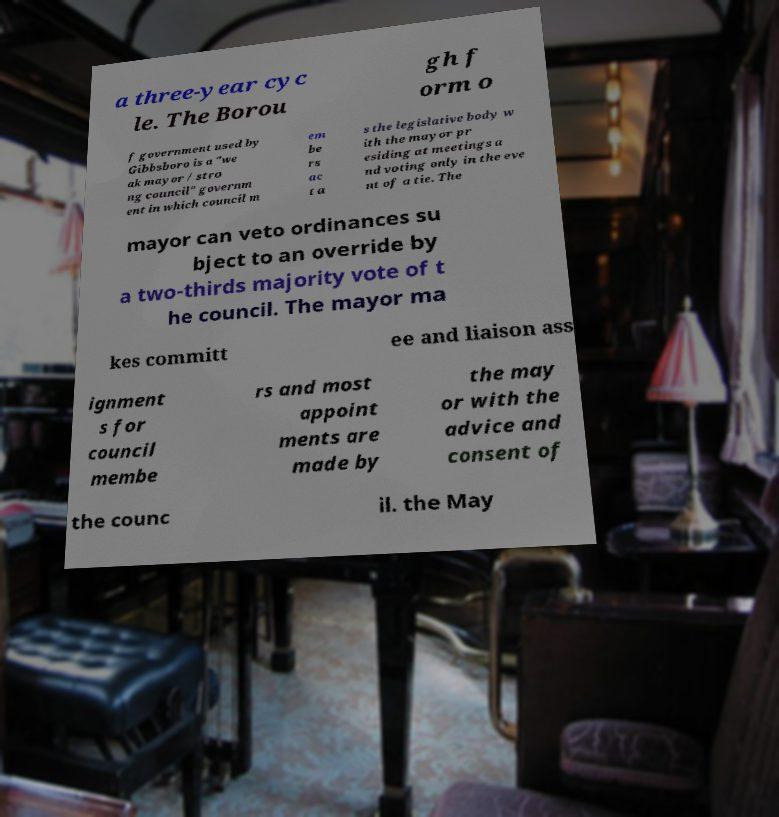Please read and relay the text visible in this image. What does it say? a three-year cyc le. The Borou gh f orm o f government used by Gibbsboro is a "we ak mayor / stro ng council" governm ent in which council m em be rs ac t a s the legislative body w ith the mayor pr esiding at meetings a nd voting only in the eve nt of a tie. The mayor can veto ordinances su bject to an override by a two-thirds majority vote of t he council. The mayor ma kes committ ee and liaison ass ignment s for council membe rs and most appoint ments are made by the may or with the advice and consent of the counc il. the May 